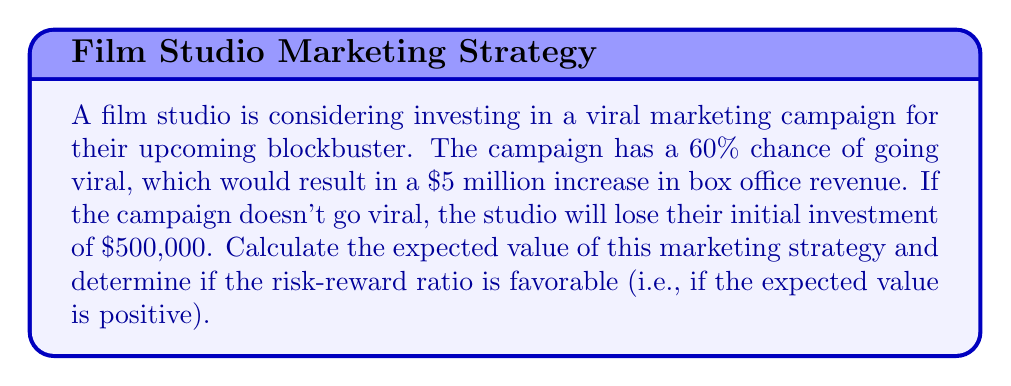Provide a solution to this math problem. To solve this problem, we need to use the concept of expected value from decision theory. The expected value is calculated by multiplying each possible outcome by its probability and then summing these products.

Let's break down the problem:

1. Probability of success (going viral): 60% = 0.6
2. Probability of failure (not going viral): 40% = 0.4
3. Reward if successful: $5,000,000
4. Loss if unsuccessful: $500,000

Now, let's calculate the expected value:

$$EV = (P_{success} \times Reward) + (P_{failure} \times (-Loss))$$

$$EV = (0.6 \times \$5,000,000) + (0.4 \times (-\$500,000))$$

$$EV = \$3,000,000 - \$200,000$$

$$EV = \$2,800,000$$

The expected value is positive, which means the risk-reward ratio is favorable. The studio can expect to gain an average of $2.8 million by implementing this viral marketing strategy.

To calculate the risk-reward ratio, we can use:

$$\text{Risk-Reward Ratio} = \frac{\text{Potential Loss}}{\text{Potential Gain}} = \frac{\$500,000}{\$5,000,000} = 0.1$$

This means that for every dollar of potential gain, the studio risks losing 10 cents. Generally, a risk-reward ratio less than 1 is considered favorable, which further supports the decision to invest in the viral marketing campaign.
Answer: The expected value of the viral marketing strategy is $2,800,000. The risk-reward ratio is favorable, as the expected value is positive and the risk-reward ratio is 0.1, which is less than 1. 